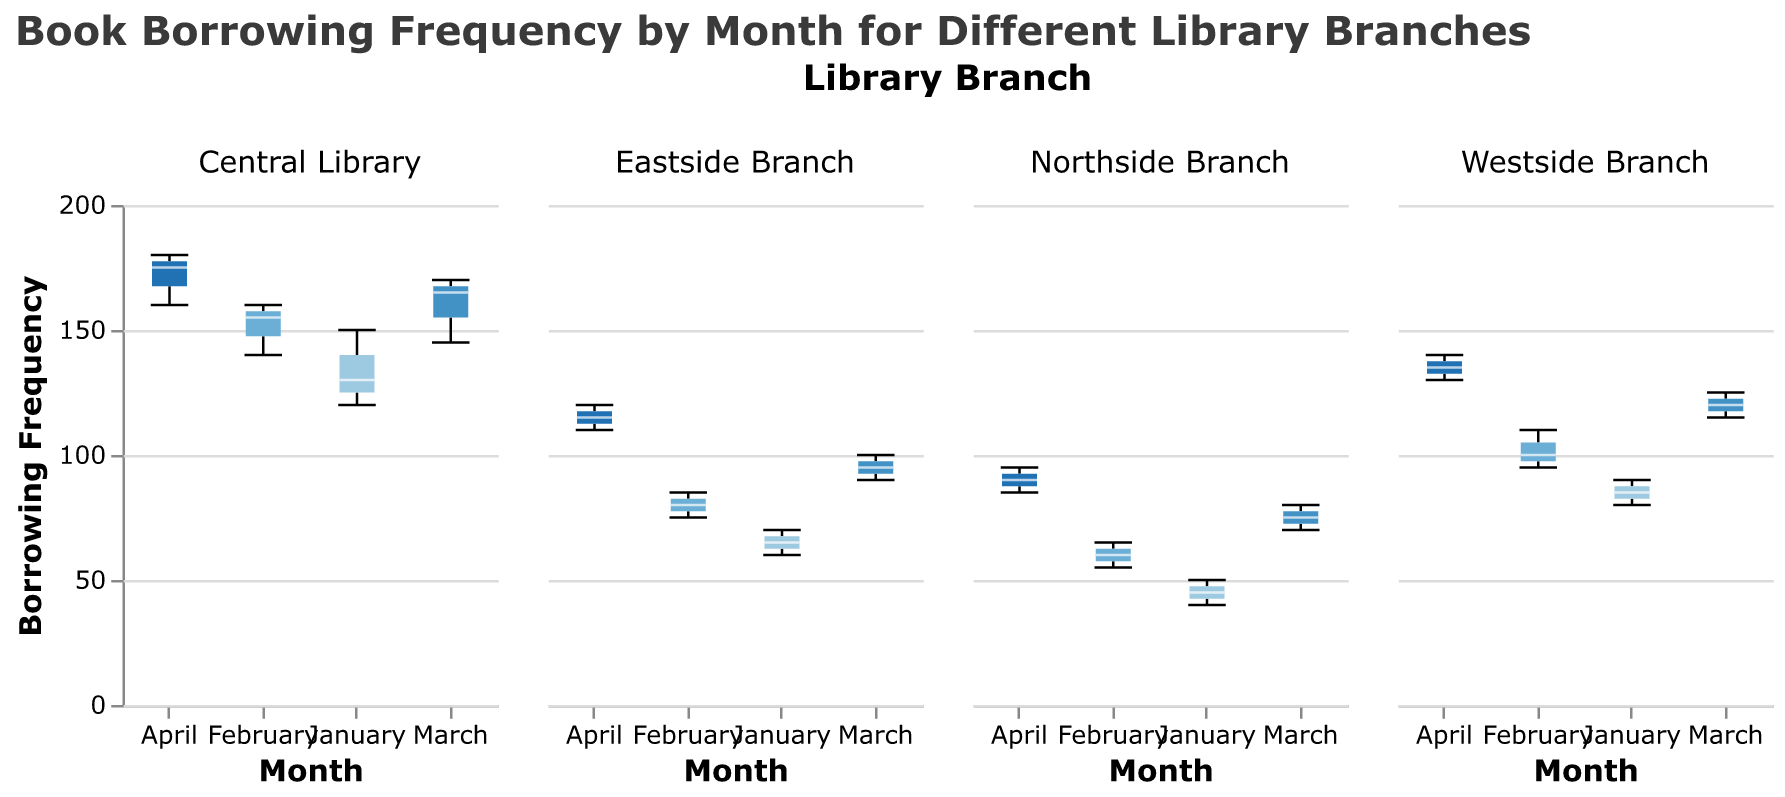How many branches are displayed in the figure? The figure shows the book borrowing frequencies for different library branches, and each subplot represents a different branch. By looking at the separate columns, we can count that there are four branches displayed in total: Central Library, Westside Branch, Eastside Branch, and Northside Branch.
Answer: 4 Which branch has the highest borrowing frequency in April? To find the answer, we look at the box plot for April in each branch's subplot and identify the branch with the highest maximum borrowing frequency. In this case, the Central Library's maximum borrowing frequency in April reaches 180, which is the highest.
Answer: Central Library What is the median borrowing frequency for the Eastside Branch in March? In the Eastside Branch subplot, locate the box plot for March. The median is represented by the line inside the box. The median borrowing frequency for March there is 95.
Answer: 95 Which month shows the greatest range of borrowing frequencies for the Westside Branch? To find the greatest range, we need to look at each month in the Westside Branch's subplot and find the one with the largest difference between the minimum and maximum values. For Westside Branch, April has the range from 130 to 140, the highest.
Answer: April Compare the borrowing frequency in January across all branches. Which branch has the lowest median borrowing frequency in January? For each branch's January subplot, identify the median line within the box. The Northside Branch's median borrowing frequency for January is the lowest at 45.
Answer: Northside Branch What is the interquartile range (IQR) for the Central Library in February? The IQR is the range between the first quartile (the bottom of the box) and the third quartile (the top of the box). For the Central Library in February, the first quartile is 140, and the third quartile is 160, so the IQR is 160 - 140 = 20.
Answer: 20 In which month does the Eastside Branch have the highest median borrowing frequency? Look at the median lines in the box plots for each month in the Eastside Branch's subplot. The highest median borrowing frequency for the Eastside Branch is in April, where it reaches 115.
Answer: April Is the variance in borrowing frequency in January greater for the Central Library or the Westside Branch? The variance is evaluated through the spread of the boxplots. In January, the Central Library's boxplot shows a wider spread (from 120 to 150) compared to the Westside Branch (from 80 to 90), indicating greater variance.
Answer: Central Library 